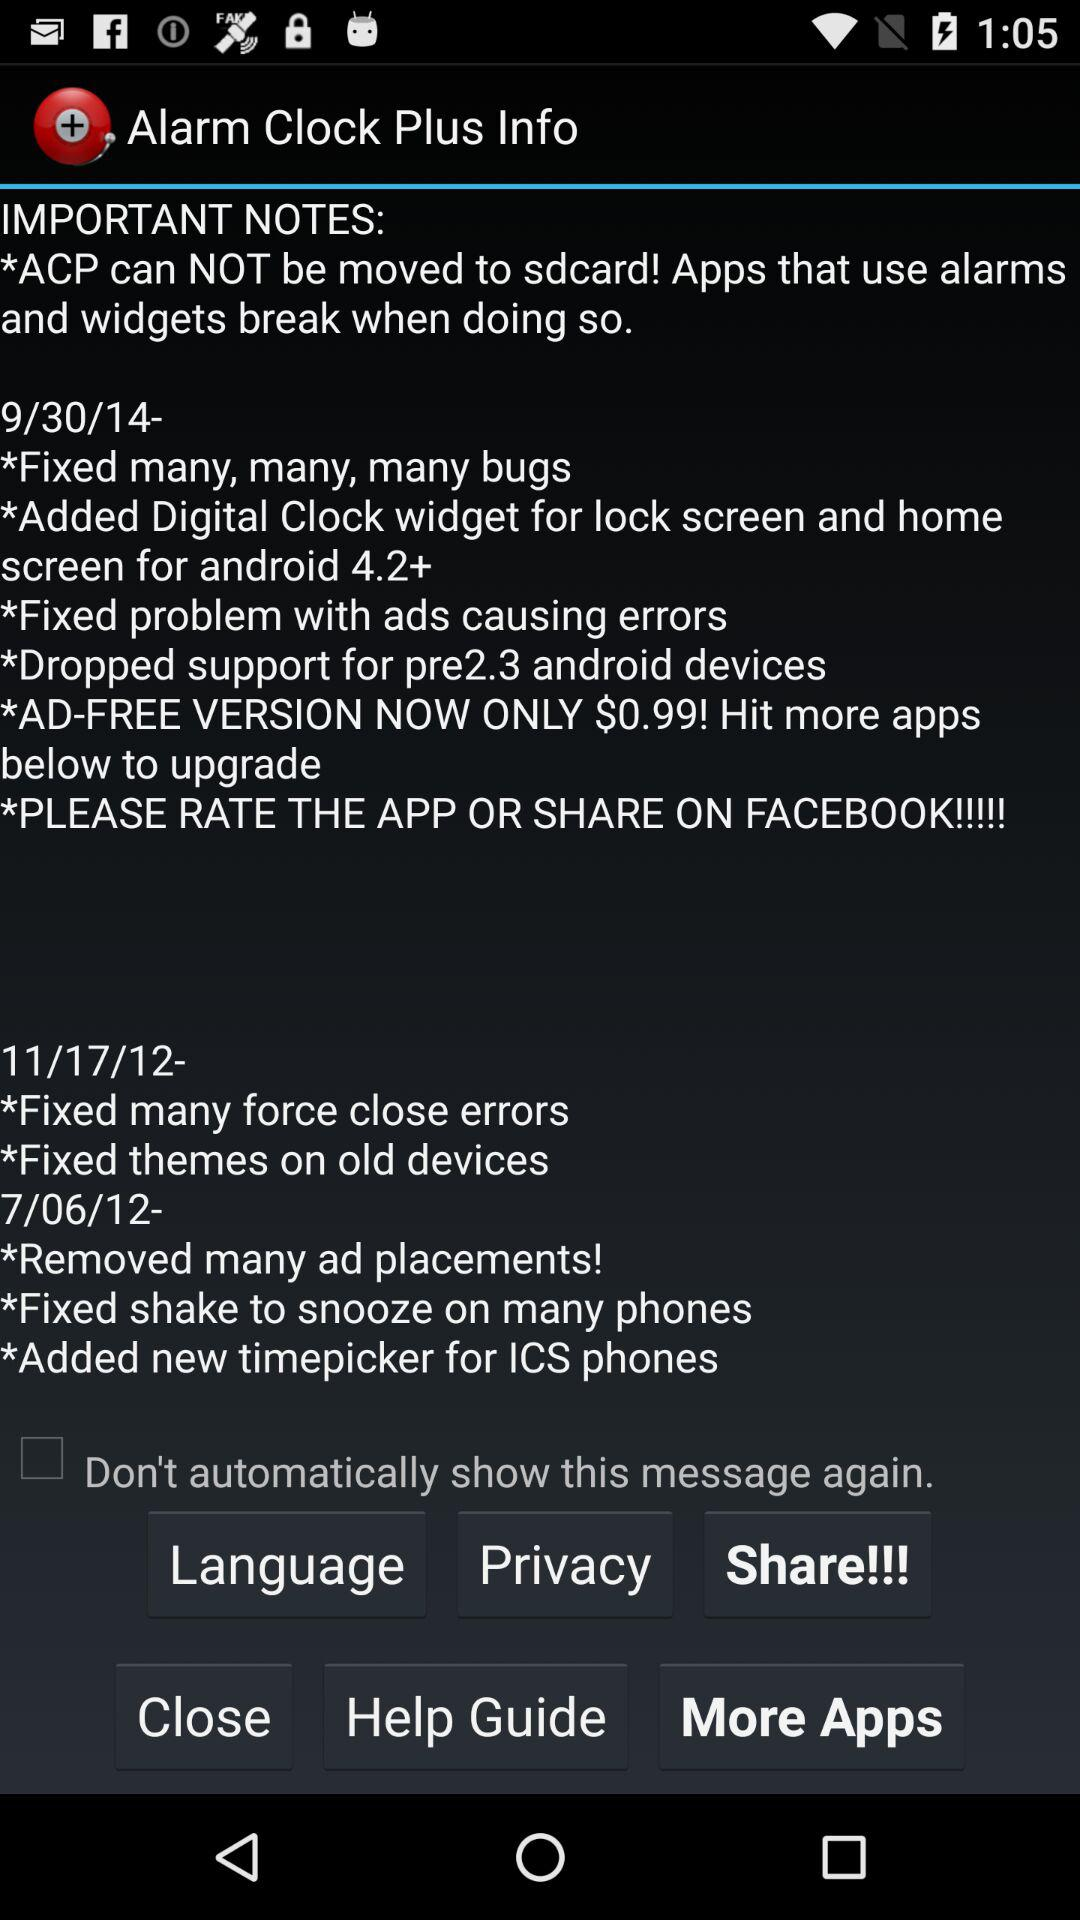What is the new update on 7/06/12? The new updates are "Removed many ad placements!", "Fixed shake to snooze on many phones" and "Added new timepicker for ICS phones". 